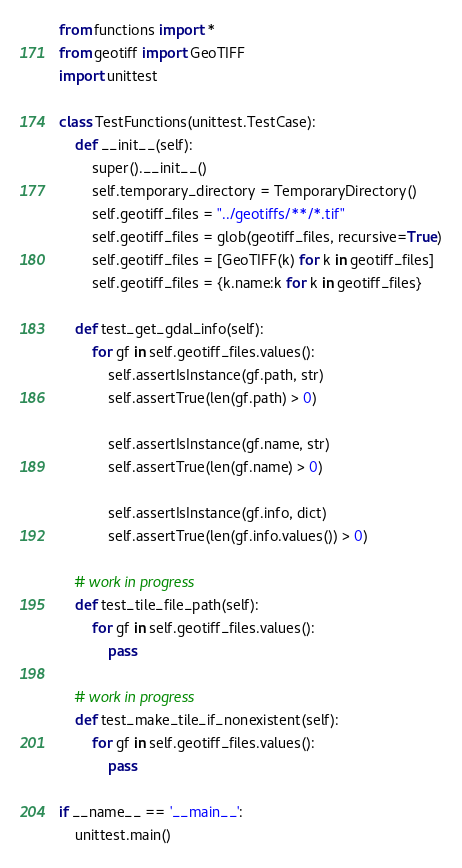<code> <loc_0><loc_0><loc_500><loc_500><_Python_>from functions import *
from geotiff import GeoTIFF
import unittest

class TestFunctions(unittest.TestCase):
    def __init__(self):
        super().__init__()
        self.temporary_directory = TemporaryDirectory()
        self.geotiff_files = "../geotiffs/**/*.tif"
        self.geotiff_files = glob(geotiff_files, recursive=True)
        self.geotiff_files = [GeoTIFF(k) for k in geotiff_files]
        self.geotiff_files = {k.name:k for k in geotiff_files}

    def test_get_gdal_info(self):
        for gf in self.geotiff_files.values():
            self.assertIsInstance(gf.path, str)
            self.assertTrue(len(gf.path) > 0)

            self.assertIsInstance(gf.name, str)
            self.assertTrue(len(gf.name) > 0)

            self.assertIsInstance(gf.info, dict)
            self.assertTrue(len(gf.info.values()) > 0)

    # work in progress
    def test_tile_file_path(self):
        for gf in self.geotiff_files.values():
            pass

    # work in progress    
    def test_make_tile_if_nonexistent(self):
        for gf in self.geotiff_files.values():
            pass

if __name__ == '__main__':
    unittest.main()</code> 